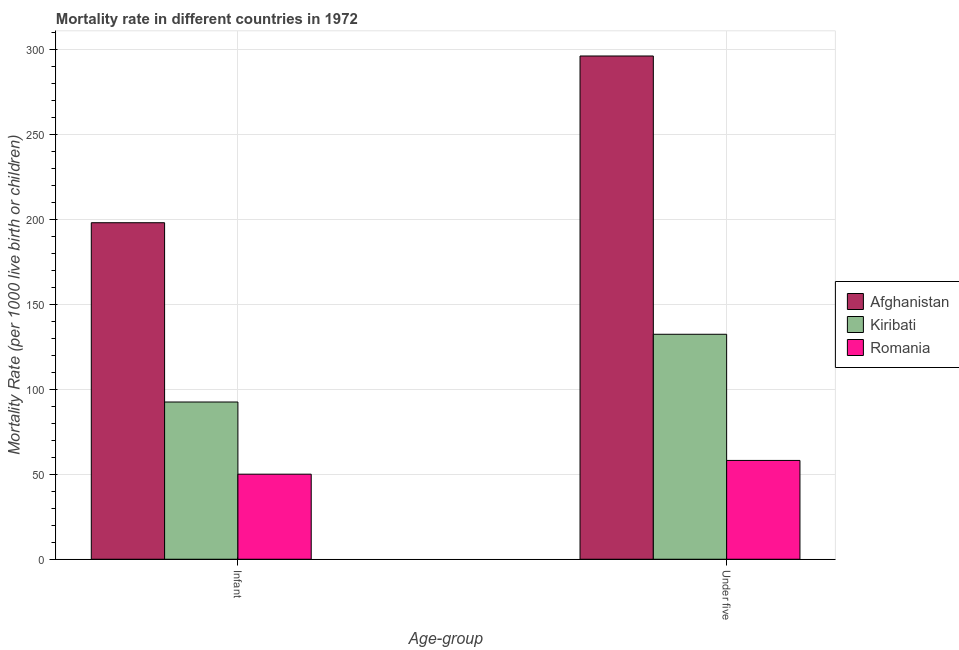How many different coloured bars are there?
Provide a short and direct response. 3. Are the number of bars on each tick of the X-axis equal?
Offer a very short reply. Yes. How many bars are there on the 2nd tick from the right?
Keep it short and to the point. 3. What is the label of the 1st group of bars from the left?
Provide a short and direct response. Infant. What is the infant mortality rate in Afghanistan?
Offer a very short reply. 198.2. Across all countries, what is the maximum infant mortality rate?
Ensure brevity in your answer.  198.2. Across all countries, what is the minimum infant mortality rate?
Keep it short and to the point. 50.1. In which country was the under-5 mortality rate maximum?
Offer a very short reply. Afghanistan. In which country was the under-5 mortality rate minimum?
Your answer should be very brief. Romania. What is the total infant mortality rate in the graph?
Your answer should be very brief. 340.9. What is the difference between the under-5 mortality rate in Afghanistan and that in Kiribati?
Your answer should be very brief. 163.9. What is the difference between the infant mortality rate in Romania and the under-5 mortality rate in Afghanistan?
Ensure brevity in your answer.  -246.3. What is the average infant mortality rate per country?
Your answer should be compact. 113.63. What is the difference between the under-5 mortality rate and infant mortality rate in Romania?
Provide a short and direct response. 8.1. What is the ratio of the infant mortality rate in Kiribati to that in Afghanistan?
Keep it short and to the point. 0.47. Is the infant mortality rate in Kiribati less than that in Afghanistan?
Offer a terse response. Yes. In how many countries, is the under-5 mortality rate greater than the average under-5 mortality rate taken over all countries?
Provide a short and direct response. 1. What does the 1st bar from the left in Under five represents?
Offer a terse response. Afghanistan. What does the 1st bar from the right in Under five represents?
Keep it short and to the point. Romania. Are all the bars in the graph horizontal?
Provide a short and direct response. No. How many countries are there in the graph?
Keep it short and to the point. 3. Are the values on the major ticks of Y-axis written in scientific E-notation?
Your answer should be compact. No. Does the graph contain grids?
Ensure brevity in your answer.  Yes. Where does the legend appear in the graph?
Provide a succinct answer. Center right. What is the title of the graph?
Offer a very short reply. Mortality rate in different countries in 1972. What is the label or title of the X-axis?
Your answer should be compact. Age-group. What is the label or title of the Y-axis?
Ensure brevity in your answer.  Mortality Rate (per 1000 live birth or children). What is the Mortality Rate (per 1000 live birth or children) of Afghanistan in Infant?
Your answer should be very brief. 198.2. What is the Mortality Rate (per 1000 live birth or children) in Kiribati in Infant?
Keep it short and to the point. 92.6. What is the Mortality Rate (per 1000 live birth or children) in Romania in Infant?
Make the answer very short. 50.1. What is the Mortality Rate (per 1000 live birth or children) of Afghanistan in Under five?
Your answer should be very brief. 296.4. What is the Mortality Rate (per 1000 live birth or children) of Kiribati in Under five?
Make the answer very short. 132.5. What is the Mortality Rate (per 1000 live birth or children) of Romania in Under five?
Offer a terse response. 58.2. Across all Age-group, what is the maximum Mortality Rate (per 1000 live birth or children) in Afghanistan?
Offer a very short reply. 296.4. Across all Age-group, what is the maximum Mortality Rate (per 1000 live birth or children) of Kiribati?
Your answer should be compact. 132.5. Across all Age-group, what is the maximum Mortality Rate (per 1000 live birth or children) of Romania?
Your answer should be very brief. 58.2. Across all Age-group, what is the minimum Mortality Rate (per 1000 live birth or children) in Afghanistan?
Provide a short and direct response. 198.2. Across all Age-group, what is the minimum Mortality Rate (per 1000 live birth or children) of Kiribati?
Make the answer very short. 92.6. Across all Age-group, what is the minimum Mortality Rate (per 1000 live birth or children) in Romania?
Give a very brief answer. 50.1. What is the total Mortality Rate (per 1000 live birth or children) of Afghanistan in the graph?
Your answer should be compact. 494.6. What is the total Mortality Rate (per 1000 live birth or children) of Kiribati in the graph?
Provide a short and direct response. 225.1. What is the total Mortality Rate (per 1000 live birth or children) in Romania in the graph?
Offer a terse response. 108.3. What is the difference between the Mortality Rate (per 1000 live birth or children) of Afghanistan in Infant and that in Under five?
Ensure brevity in your answer.  -98.2. What is the difference between the Mortality Rate (per 1000 live birth or children) of Kiribati in Infant and that in Under five?
Give a very brief answer. -39.9. What is the difference between the Mortality Rate (per 1000 live birth or children) of Afghanistan in Infant and the Mortality Rate (per 1000 live birth or children) of Kiribati in Under five?
Your answer should be very brief. 65.7. What is the difference between the Mortality Rate (per 1000 live birth or children) of Afghanistan in Infant and the Mortality Rate (per 1000 live birth or children) of Romania in Under five?
Offer a terse response. 140. What is the difference between the Mortality Rate (per 1000 live birth or children) of Kiribati in Infant and the Mortality Rate (per 1000 live birth or children) of Romania in Under five?
Provide a succinct answer. 34.4. What is the average Mortality Rate (per 1000 live birth or children) of Afghanistan per Age-group?
Offer a very short reply. 247.3. What is the average Mortality Rate (per 1000 live birth or children) in Kiribati per Age-group?
Provide a short and direct response. 112.55. What is the average Mortality Rate (per 1000 live birth or children) in Romania per Age-group?
Make the answer very short. 54.15. What is the difference between the Mortality Rate (per 1000 live birth or children) of Afghanistan and Mortality Rate (per 1000 live birth or children) of Kiribati in Infant?
Your answer should be compact. 105.6. What is the difference between the Mortality Rate (per 1000 live birth or children) of Afghanistan and Mortality Rate (per 1000 live birth or children) of Romania in Infant?
Your answer should be compact. 148.1. What is the difference between the Mortality Rate (per 1000 live birth or children) in Kiribati and Mortality Rate (per 1000 live birth or children) in Romania in Infant?
Your answer should be very brief. 42.5. What is the difference between the Mortality Rate (per 1000 live birth or children) of Afghanistan and Mortality Rate (per 1000 live birth or children) of Kiribati in Under five?
Keep it short and to the point. 163.9. What is the difference between the Mortality Rate (per 1000 live birth or children) of Afghanistan and Mortality Rate (per 1000 live birth or children) of Romania in Under five?
Keep it short and to the point. 238.2. What is the difference between the Mortality Rate (per 1000 live birth or children) of Kiribati and Mortality Rate (per 1000 live birth or children) of Romania in Under five?
Keep it short and to the point. 74.3. What is the ratio of the Mortality Rate (per 1000 live birth or children) in Afghanistan in Infant to that in Under five?
Provide a short and direct response. 0.67. What is the ratio of the Mortality Rate (per 1000 live birth or children) of Kiribati in Infant to that in Under five?
Provide a succinct answer. 0.7. What is the ratio of the Mortality Rate (per 1000 live birth or children) of Romania in Infant to that in Under five?
Offer a terse response. 0.86. What is the difference between the highest and the second highest Mortality Rate (per 1000 live birth or children) of Afghanistan?
Offer a very short reply. 98.2. What is the difference between the highest and the second highest Mortality Rate (per 1000 live birth or children) of Kiribati?
Your response must be concise. 39.9. What is the difference between the highest and the second highest Mortality Rate (per 1000 live birth or children) in Romania?
Ensure brevity in your answer.  8.1. What is the difference between the highest and the lowest Mortality Rate (per 1000 live birth or children) in Afghanistan?
Your answer should be compact. 98.2. What is the difference between the highest and the lowest Mortality Rate (per 1000 live birth or children) of Kiribati?
Give a very brief answer. 39.9. What is the difference between the highest and the lowest Mortality Rate (per 1000 live birth or children) in Romania?
Ensure brevity in your answer.  8.1. 